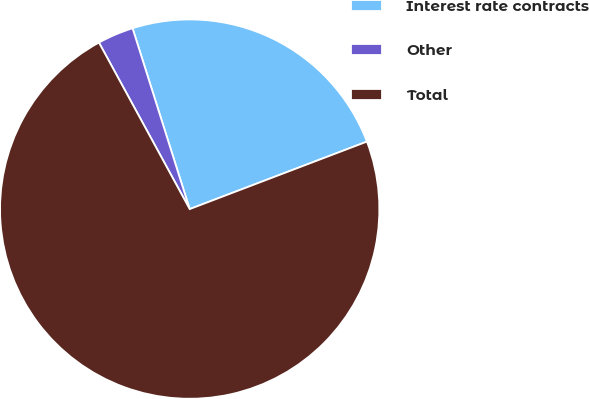<chart> <loc_0><loc_0><loc_500><loc_500><pie_chart><fcel>Interest rate contracts<fcel>Other<fcel>Total<nl><fcel>24.08%<fcel>3.07%<fcel>72.85%<nl></chart> 